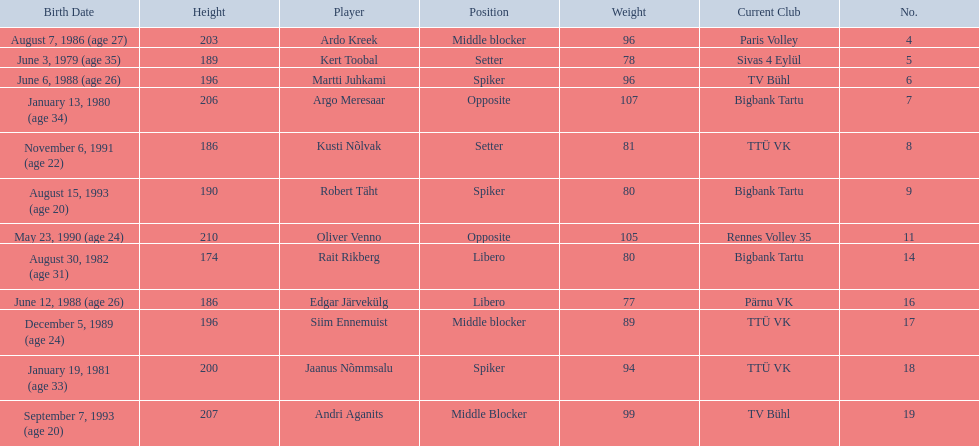Who are all of the players? Ardo Kreek, Kert Toobal, Martti Juhkami, Argo Meresaar, Kusti Nõlvak, Robert Täht, Oliver Venno, Rait Rikberg, Edgar Järvekülg, Siim Ennemuist, Jaanus Nõmmsalu, Andri Aganits. How tall are they? 203, 189, 196, 206, 186, 190, 210, 174, 186, 196, 200, 207. And which player is tallest? Oliver Venno. 